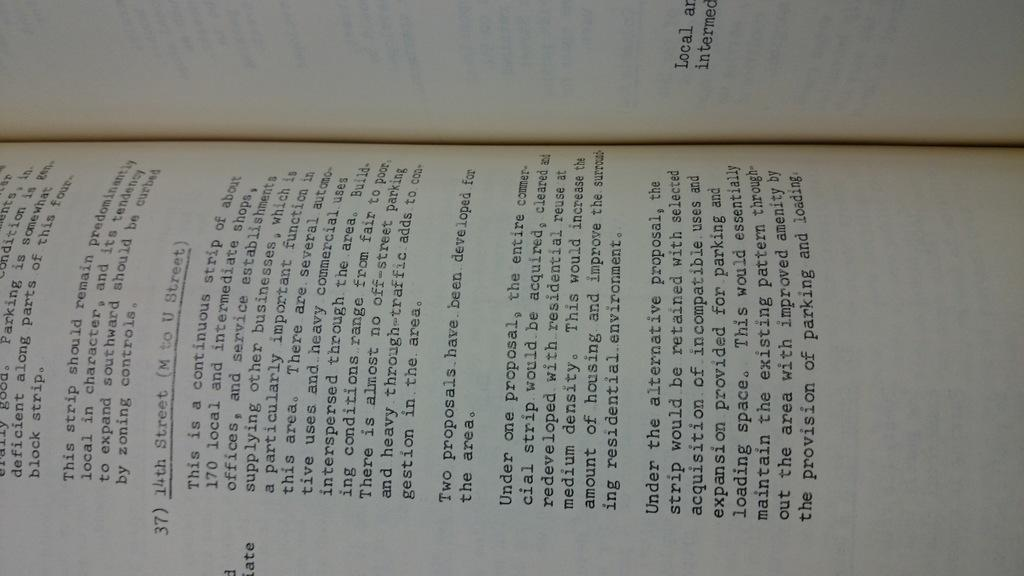<image>
Provide a brief description of the given image. Open page on a book with the number 37 on it. 